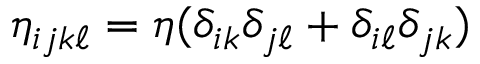<formula> <loc_0><loc_0><loc_500><loc_500>\eta _ { i j k \ell } = \eta ( \delta _ { i k } \delta _ { j \ell } + \delta _ { i \ell } \delta _ { j k } )</formula> 